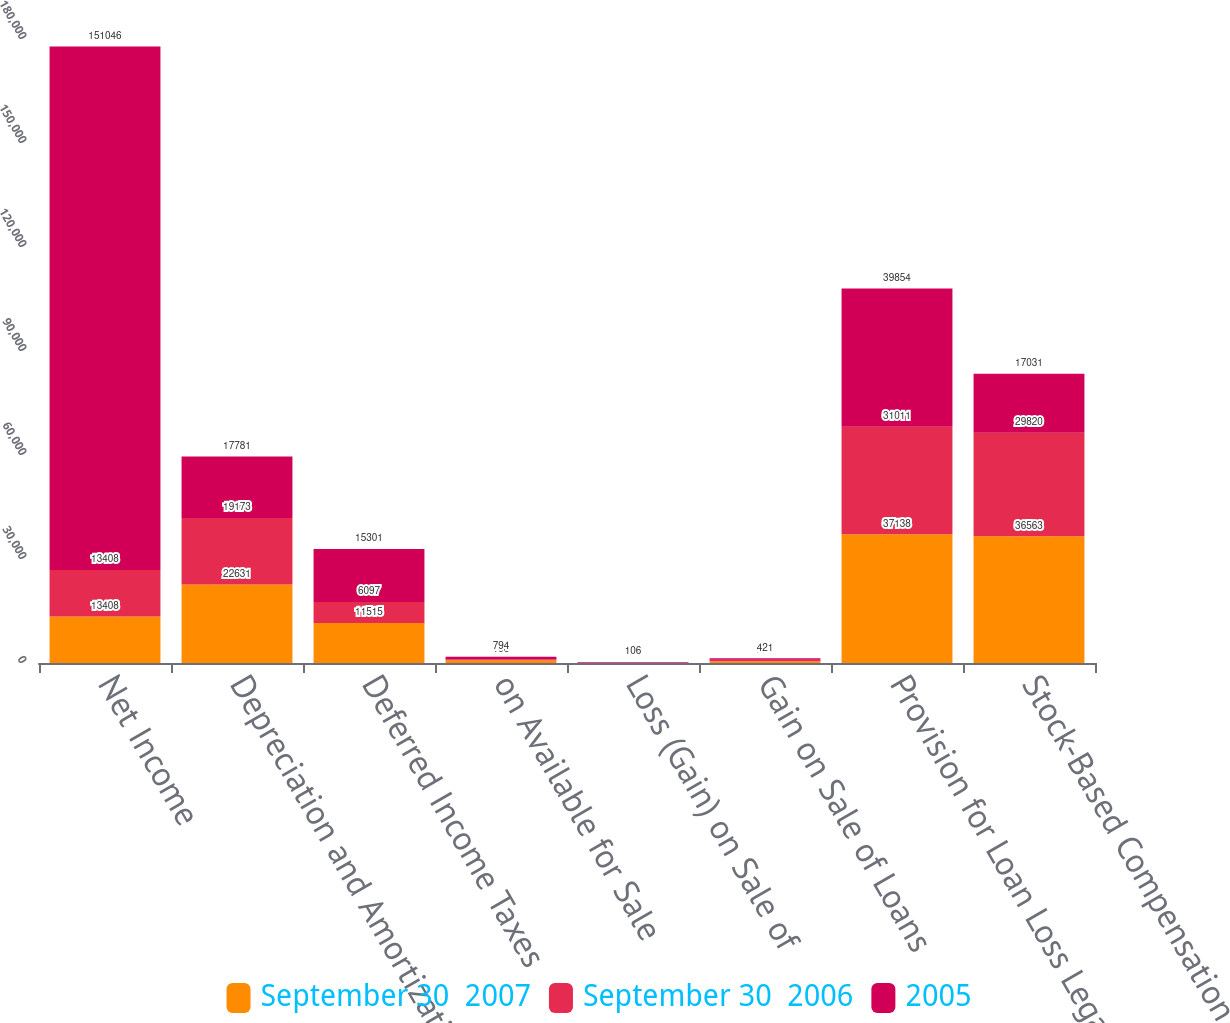<chart> <loc_0><loc_0><loc_500><loc_500><stacked_bar_chart><ecel><fcel>Net Income<fcel>Depreciation and Amortization<fcel>Deferred Income Taxes<fcel>on Available for Sale<fcel>Loss (Gain) on Sale of<fcel>Gain on Sale of Loans<fcel>Provision for Loan Loss Legal<fcel>Stock-Based Compensation<nl><fcel>September 30  2007<fcel>13408<fcel>22631<fcel>11515<fcel>790<fcel>20<fcel>518<fcel>37138<fcel>36563<nl><fcel>September 30  2006<fcel>13408<fcel>19173<fcel>6097<fcel>196<fcel>143<fcel>413<fcel>31011<fcel>29820<nl><fcel>2005<fcel>151046<fcel>17781<fcel>15301<fcel>794<fcel>106<fcel>421<fcel>39854<fcel>17031<nl></chart> 